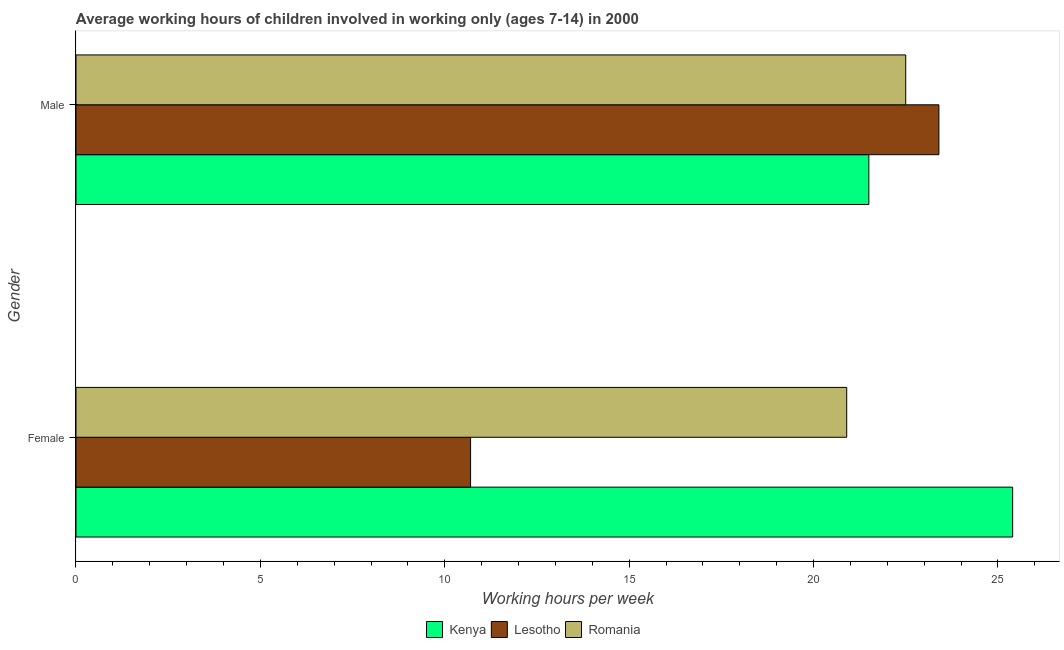How many different coloured bars are there?
Offer a very short reply. 3. How many groups of bars are there?
Provide a short and direct response. 2. Are the number of bars per tick equal to the number of legend labels?
Offer a terse response. Yes. Are the number of bars on each tick of the Y-axis equal?
Your answer should be compact. Yes. How many bars are there on the 2nd tick from the top?
Ensure brevity in your answer.  3. What is the average working hour of male children in Romania?
Make the answer very short. 22.5. Across all countries, what is the maximum average working hour of male children?
Your answer should be very brief. 23.4. Across all countries, what is the minimum average working hour of male children?
Your answer should be very brief. 21.5. In which country was the average working hour of male children maximum?
Offer a terse response. Lesotho. In which country was the average working hour of male children minimum?
Provide a succinct answer. Kenya. What is the total average working hour of male children in the graph?
Offer a terse response. 67.4. What is the difference between the average working hour of female children in Kenya and the average working hour of male children in Romania?
Provide a short and direct response. 2.9. What is the average average working hour of female children per country?
Provide a succinct answer. 19. What is the ratio of the average working hour of female children in Lesotho to that in Romania?
Your answer should be compact. 0.51. Is the average working hour of male children in Kenya less than that in Lesotho?
Your answer should be very brief. Yes. What does the 3rd bar from the top in Male represents?
Ensure brevity in your answer.  Kenya. What does the 3rd bar from the bottom in Male represents?
Your answer should be very brief. Romania. How many countries are there in the graph?
Your answer should be compact. 3. What is the difference between two consecutive major ticks on the X-axis?
Ensure brevity in your answer.  5. Does the graph contain any zero values?
Your answer should be compact. No. Does the graph contain grids?
Ensure brevity in your answer.  No. Where does the legend appear in the graph?
Your answer should be compact. Bottom center. How are the legend labels stacked?
Your answer should be very brief. Horizontal. What is the title of the graph?
Make the answer very short. Average working hours of children involved in working only (ages 7-14) in 2000. Does "Brunei Darussalam" appear as one of the legend labels in the graph?
Offer a very short reply. No. What is the label or title of the X-axis?
Provide a succinct answer. Working hours per week. What is the Working hours per week in Kenya in Female?
Offer a terse response. 25.4. What is the Working hours per week in Lesotho in Female?
Provide a succinct answer. 10.7. What is the Working hours per week of Romania in Female?
Your answer should be very brief. 20.9. What is the Working hours per week in Lesotho in Male?
Provide a succinct answer. 23.4. What is the Working hours per week of Romania in Male?
Your answer should be very brief. 22.5. Across all Gender, what is the maximum Working hours per week of Kenya?
Offer a terse response. 25.4. Across all Gender, what is the maximum Working hours per week of Lesotho?
Your response must be concise. 23.4. Across all Gender, what is the maximum Working hours per week in Romania?
Provide a succinct answer. 22.5. Across all Gender, what is the minimum Working hours per week of Kenya?
Your answer should be compact. 21.5. Across all Gender, what is the minimum Working hours per week in Romania?
Keep it short and to the point. 20.9. What is the total Working hours per week of Kenya in the graph?
Give a very brief answer. 46.9. What is the total Working hours per week of Lesotho in the graph?
Keep it short and to the point. 34.1. What is the total Working hours per week in Romania in the graph?
Provide a short and direct response. 43.4. What is the difference between the Working hours per week of Kenya in Female and that in Male?
Offer a very short reply. 3.9. What is the average Working hours per week of Kenya per Gender?
Provide a short and direct response. 23.45. What is the average Working hours per week in Lesotho per Gender?
Give a very brief answer. 17.05. What is the average Working hours per week in Romania per Gender?
Offer a terse response. 21.7. What is the difference between the Working hours per week of Kenya and Working hours per week of Romania in Female?
Your response must be concise. 4.5. What is the difference between the Working hours per week of Lesotho and Working hours per week of Romania in Female?
Give a very brief answer. -10.2. What is the difference between the Working hours per week of Kenya and Working hours per week of Lesotho in Male?
Offer a very short reply. -1.9. What is the ratio of the Working hours per week in Kenya in Female to that in Male?
Your response must be concise. 1.18. What is the ratio of the Working hours per week of Lesotho in Female to that in Male?
Keep it short and to the point. 0.46. What is the ratio of the Working hours per week of Romania in Female to that in Male?
Provide a succinct answer. 0.93. What is the difference between the highest and the second highest Working hours per week in Romania?
Offer a terse response. 1.6. 